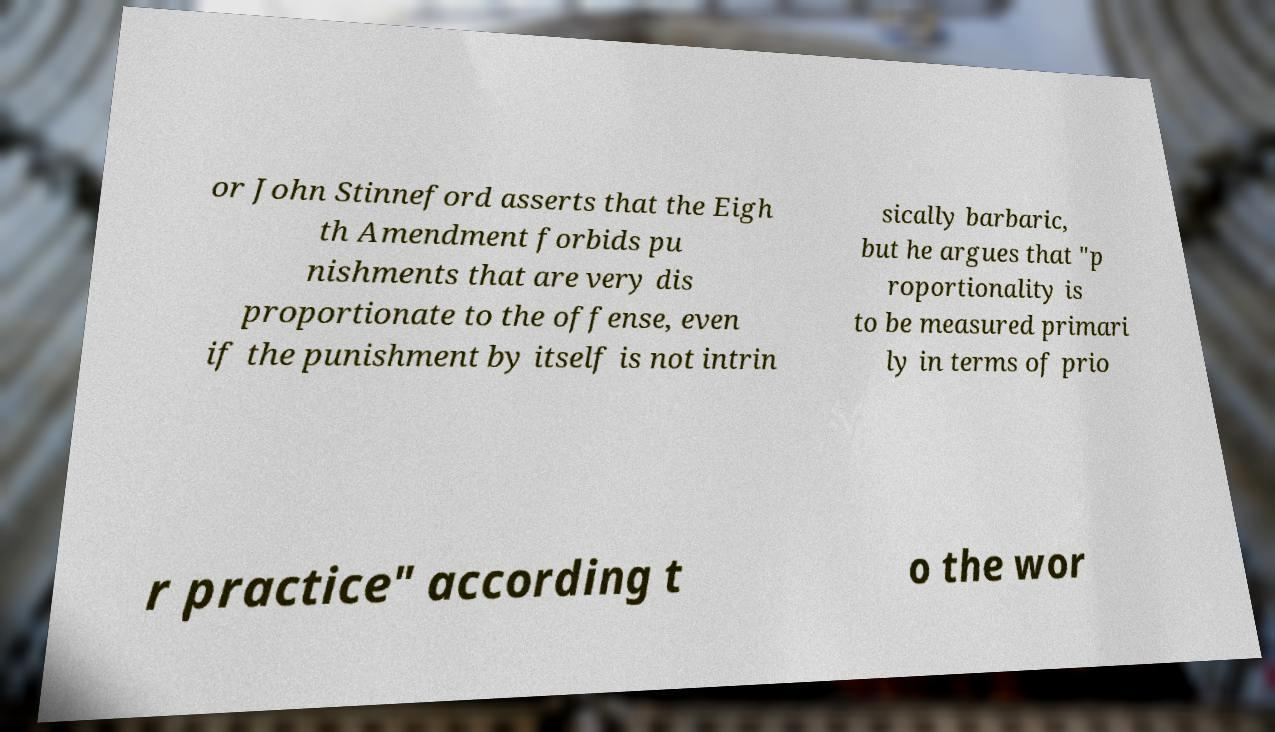I need the written content from this picture converted into text. Can you do that? or John Stinneford asserts that the Eigh th Amendment forbids pu nishments that are very dis proportionate to the offense, even if the punishment by itself is not intrin sically barbaric, but he argues that "p roportionality is to be measured primari ly in terms of prio r practice" according t o the wor 